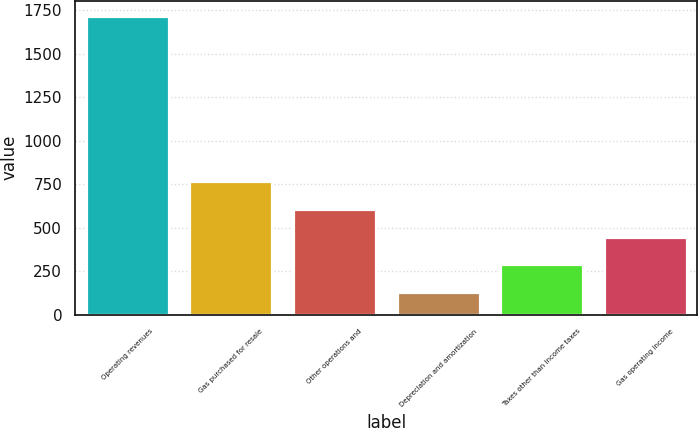<chart> <loc_0><loc_0><loc_500><loc_500><bar_chart><fcel>Operating revenues<fcel>Gas purchased for resale<fcel>Other operations and<fcel>Depreciation and amortization<fcel>Taxes other than income taxes<fcel>Gas operating income<nl><fcel>1721<fcel>767.6<fcel>608.7<fcel>132<fcel>290.9<fcel>449.8<nl></chart> 